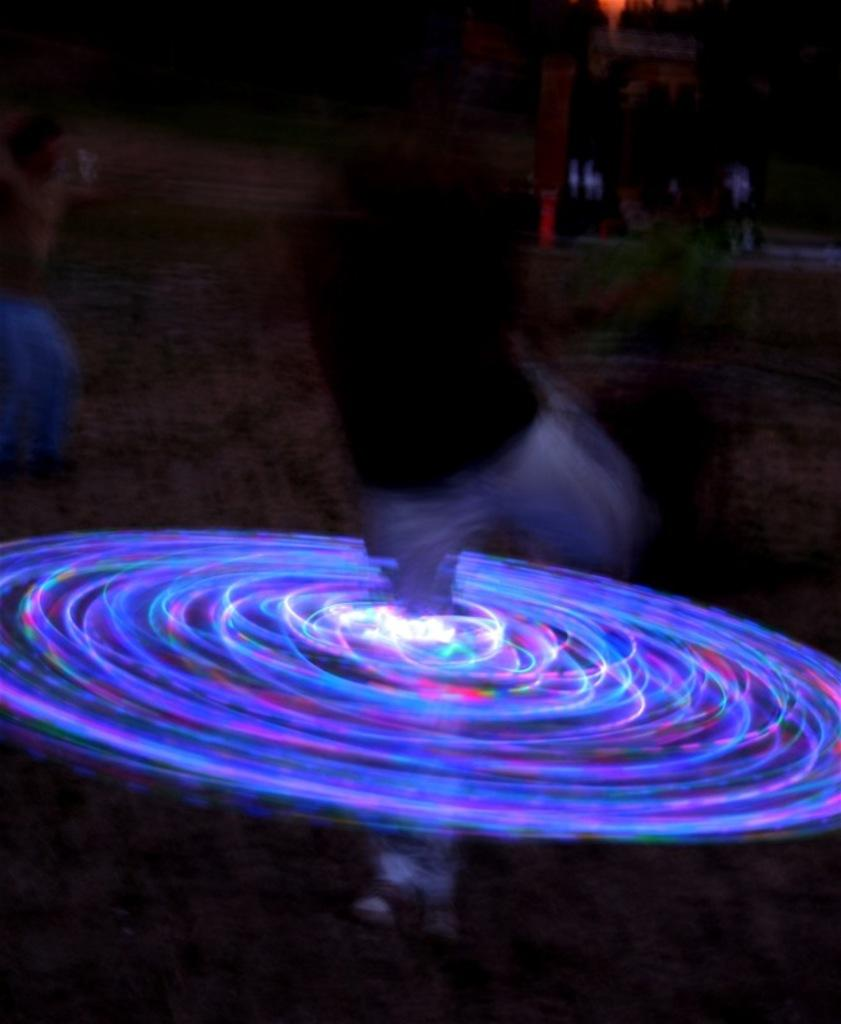Who or what is present in the image? There is a person in the image. What is unique about the person's appearance in the image? There are round lights around the person's legs. What type of carriage is being pulled by the hen in the image? There is no carriage or hen present in the image; it only features a person with round lights around their legs. 